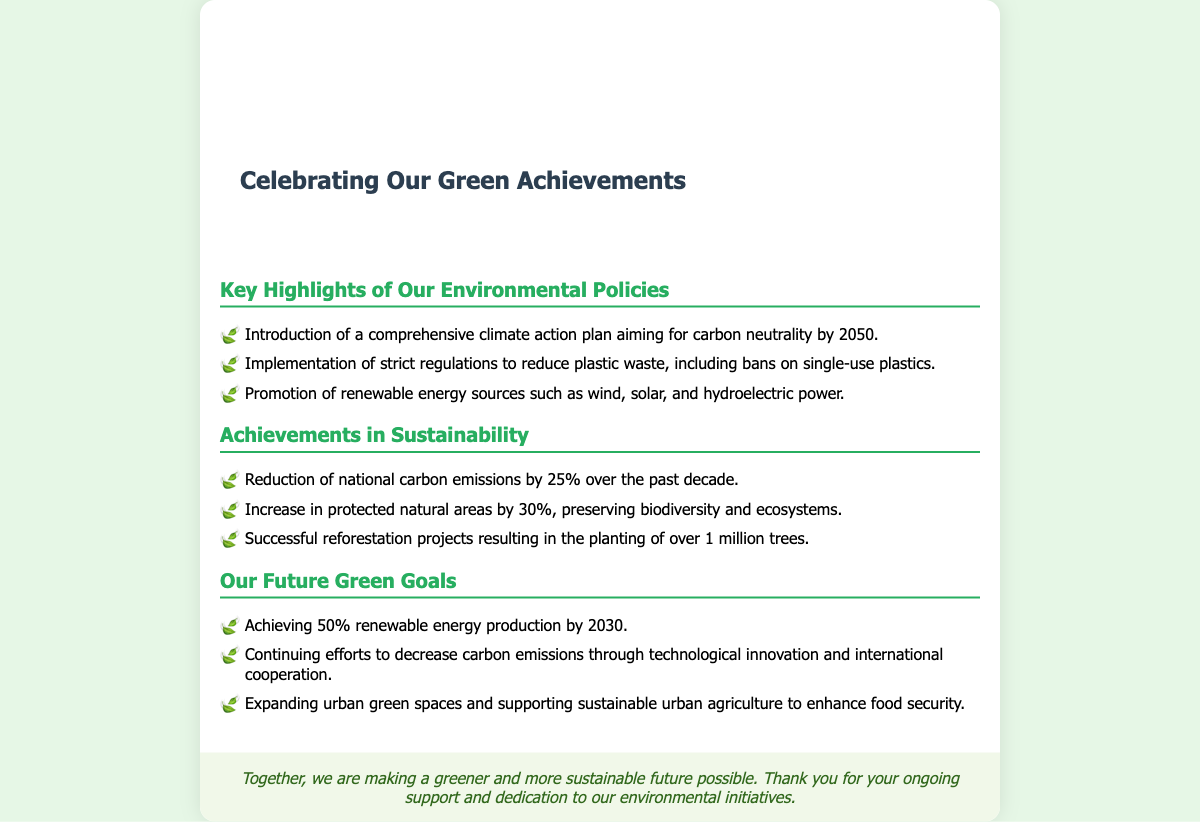What is the title of the card? The title is prominently displayed at the top of the card and is "Celebrating Our Green Achievements."
Answer: Celebrating Our Green Achievements What is the carbon neutrality target year? The document mentions a comprehensive climate action plan aiming for carbon neutrality by a specific year.
Answer: 2050 How much have national carbon emissions been reduced? The document states the percentage reduction of national carbon emissions achieved over the past decade.
Answer: 25% What is the increase in protected natural areas? The document mentions the percentage increase in protected natural areas to indicate achievements in sustainability.
Answer: 30% What is one of the future green goals? The document lists various goals for the future; one of them is a clear target for renewable energy production.
Answer: 50% renewable energy production by 2030 How many trees have been planted in reforestation projects? The document specifies the number of trees planted as part of successful reforestation projects.
Answer: Over 1 million trees What type of policies are highlighted in the document? The card features specific environmental policies implemented by the organization, showcasing their commitment.
Answer: Environmental Policies What is being promoted to reduce plastic waste? The document discusses certain actions taken to address plastic waste among the achieved highlights.
Answer: Bans on single-use plastics What is the role of urban green spaces according to the card? The section on future green goals mentions how expanding urban green spaces supports a particular concept.
Answer: Enhance food security 